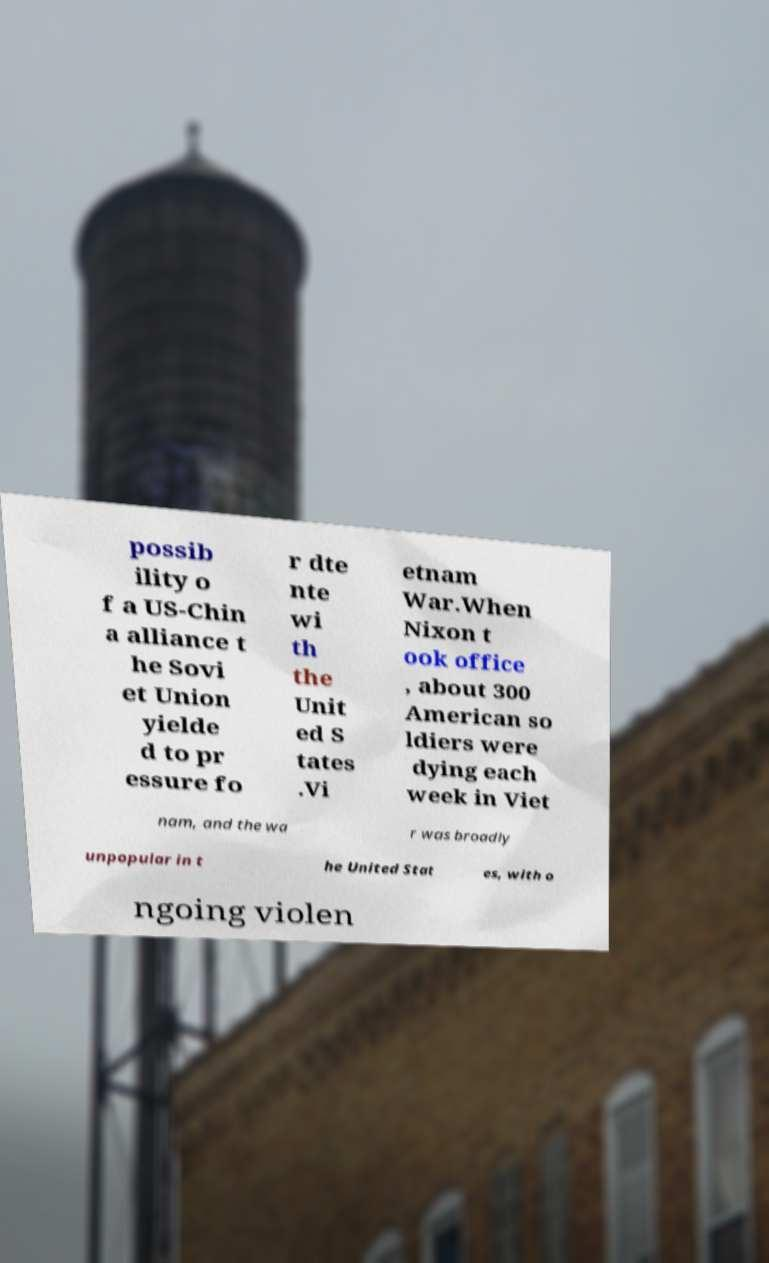There's text embedded in this image that I need extracted. Can you transcribe it verbatim? possib ility o f a US-Chin a alliance t he Sovi et Union yielde d to pr essure fo r dte nte wi th the Unit ed S tates .Vi etnam War.When Nixon t ook office , about 300 American so ldiers were dying each week in Viet nam, and the wa r was broadly unpopular in t he United Stat es, with o ngoing violen 